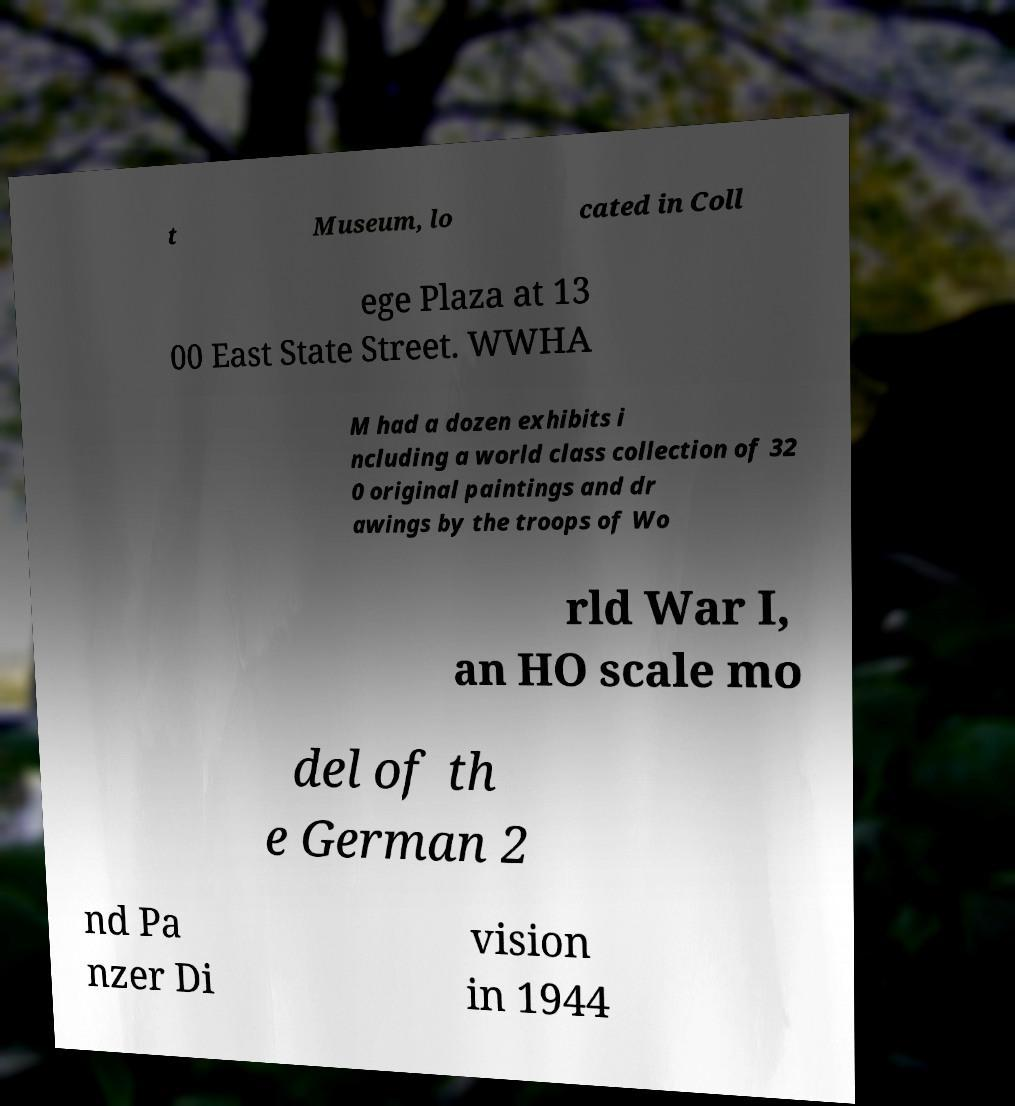Can you accurately transcribe the text from the provided image for me? t Museum, lo cated in Coll ege Plaza at 13 00 East State Street. WWHA M had a dozen exhibits i ncluding a world class collection of 32 0 original paintings and dr awings by the troops of Wo rld War I, an HO scale mo del of th e German 2 nd Pa nzer Di vision in 1944 